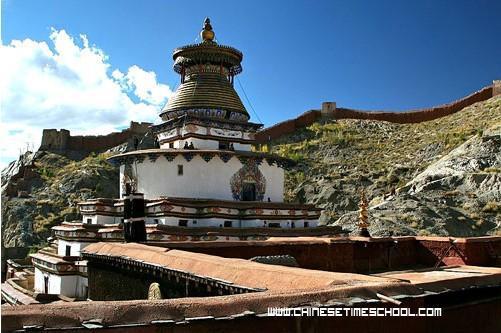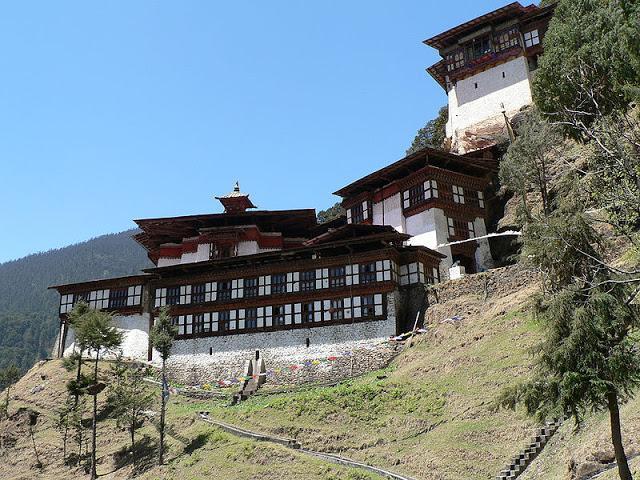The first image is the image on the left, the second image is the image on the right. Evaluate the accuracy of this statement regarding the images: "An image shows people walking down a wide paved path toward a row of arches with a dome-topped tower behind them.". Is it true? Answer yes or no. No. The first image is the image on the left, the second image is the image on the right. Assess this claim about the two images: "There is a building with a blue dome in at least one of the images.". Correct or not? Answer yes or no. No. 